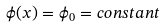Convert formula to latex. <formula><loc_0><loc_0><loc_500><loc_500>\phi ( x ) = \phi _ { 0 } = c o n s t a n t</formula> 